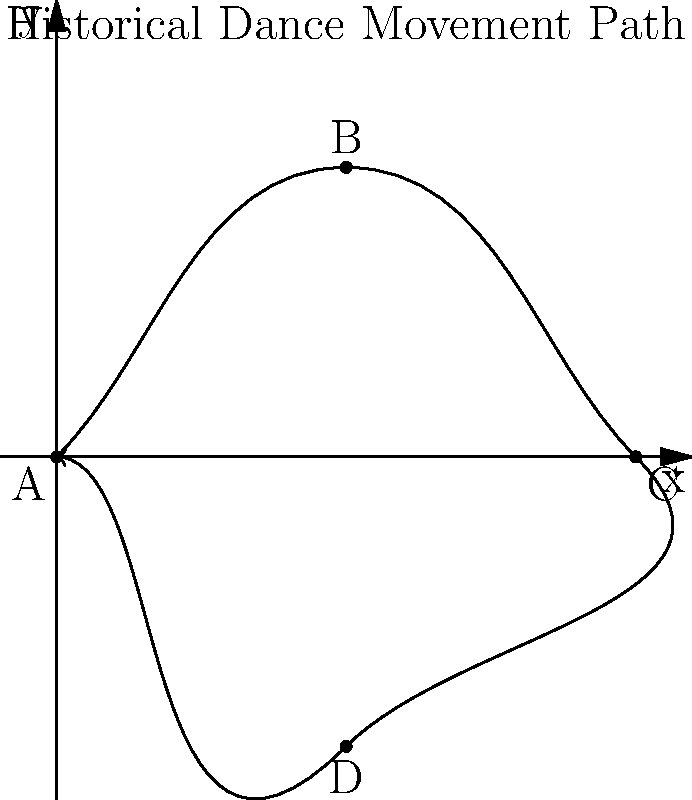In your research for your historical fiction novel, you come across a diagram representing a traditional dance movement from the era you're writing about. The motion path is shown above. If a dancer completes this movement in 8 seconds at a constant speed, what is the average velocity vector of the dancer? To find the average velocity vector, we need to follow these steps:

1. Identify the start and end points of the motion:
   Start point A: (0,0)
   End point A: (0,0)

2. Calculate the displacement vector:
   Displacement = End point - Start point
   Displacement = (0,0) - (0,0) = (0,0)

3. Calculate the time taken:
   Time = 8 seconds

4. Use the formula for average velocity:
   $\vec{v}_{avg} = \frac{\Delta \vec{r}}{\Delta t}$
   
   Where $\Delta \vec{r}$ is the displacement vector and $\Delta t$ is the time taken.

5. Substitute the values:
   $\vec{v}_{avg} = \frac{(0,0)}{8} = (0,0)$ m/s

The average velocity vector is (0,0) m/s because the dancer starts and ends at the same point, resulting in zero net displacement over the 8-second interval.
Answer: $(0,0)$ m/s 